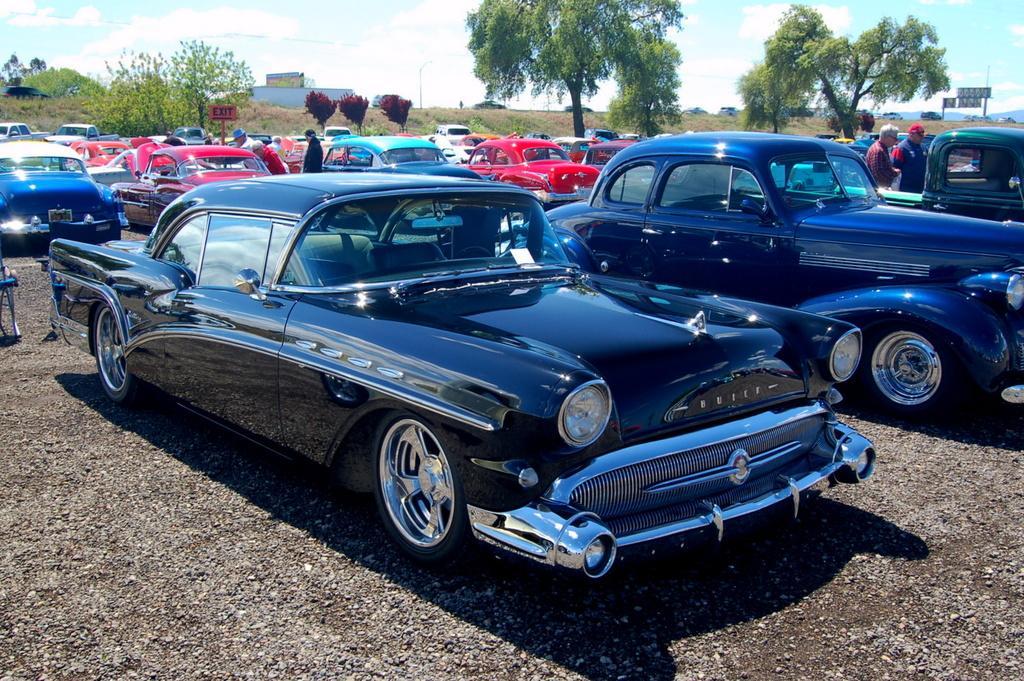Can you describe this image briefly? In this image we can see a group of cars placed on the ground. On the backside we can see some trees, some people standing, a signboard, grass, poles, a street pole, wall and the sky which looks cloudy. 